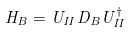<formula> <loc_0><loc_0><loc_500><loc_500>H _ { B } = U _ { I I } D _ { B } U _ { I I } ^ { \dagger }</formula> 